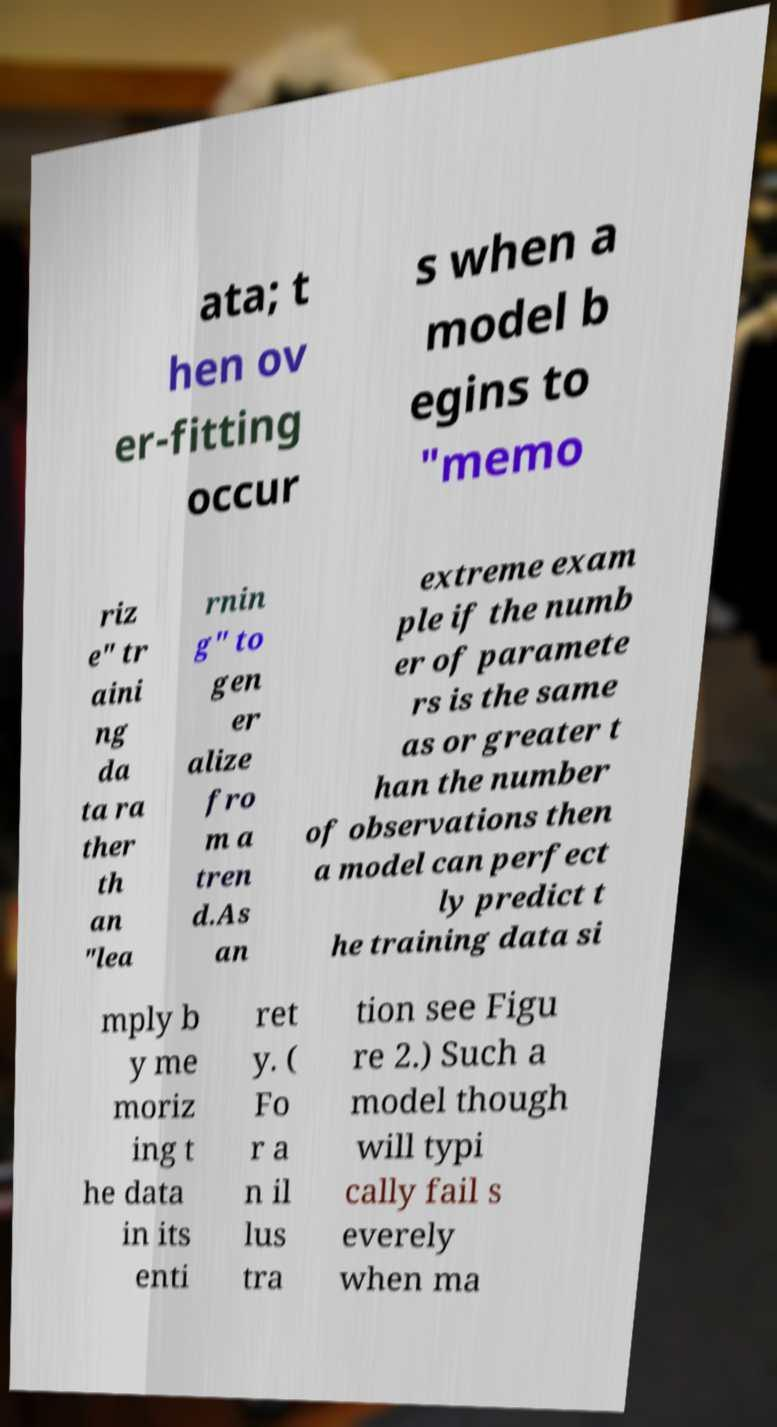What messages or text are displayed in this image? I need them in a readable, typed format. ata; t hen ov er-fitting occur s when a model b egins to "memo riz e" tr aini ng da ta ra ther th an "lea rnin g" to gen er alize fro m a tren d.As an extreme exam ple if the numb er of paramete rs is the same as or greater t han the number of observations then a model can perfect ly predict t he training data si mply b y me moriz ing t he data in its enti ret y. ( Fo r a n il lus tra tion see Figu re 2.) Such a model though will typi cally fail s everely when ma 